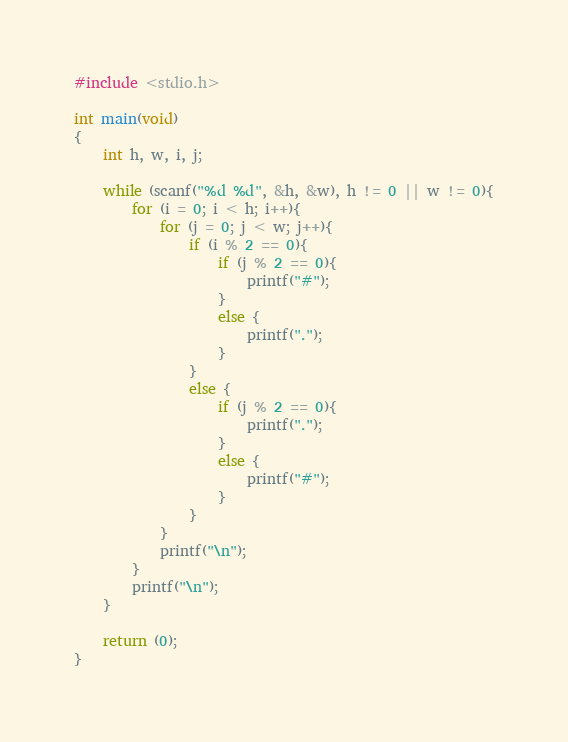<code> <loc_0><loc_0><loc_500><loc_500><_C_>#include <stdio.h>

int main(void)
{
	int h, w, i, j;
	
	while (scanf("%d %d", &h, &w), h != 0 || w != 0){
		for (i = 0; i < h; i++){
			for (j = 0; j < w; j++){
				if (i % 2 == 0){
					if (j % 2 == 0){
						printf("#");
					}
					else {
						printf(".");
					}
				}
				else {
					if (j % 2 == 0){
						printf(".");
					}
					else {
						printf("#");
					}
				}
			}
			printf("\n");
		}
		printf("\n");
	}
	
	return (0);
}</code> 